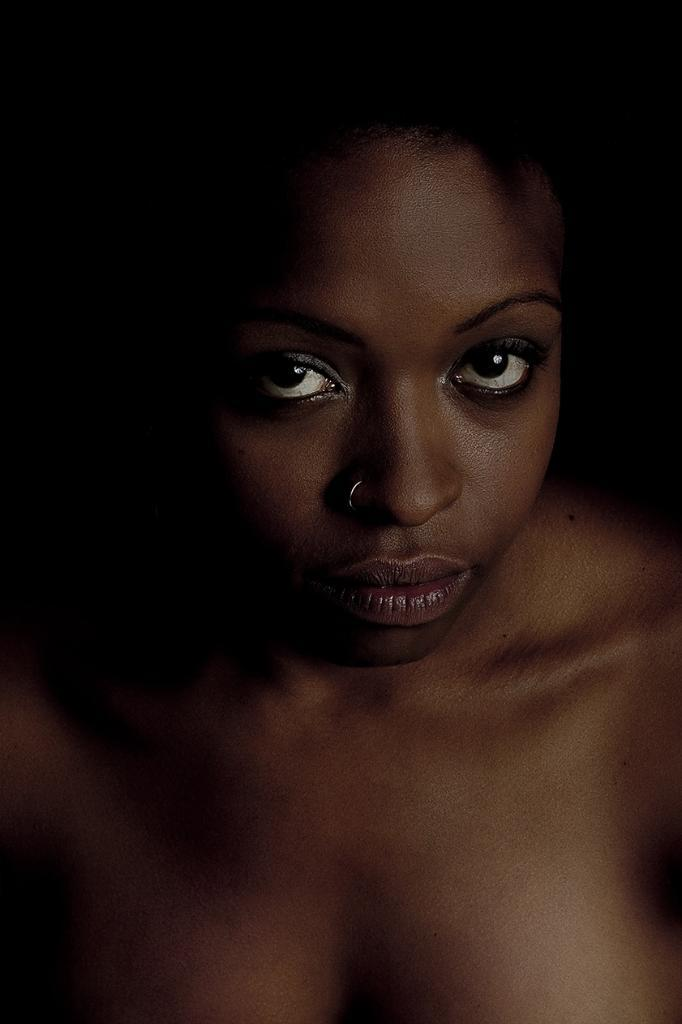What is the main subject of the image? There is a girl's face in the image. What type of coast can be seen in the background of the image? There is no coast visible in the image; it only features a girl's face. What type of bread is the girl holding in the image? There is no bread present in the image; it only features a girl's face. 